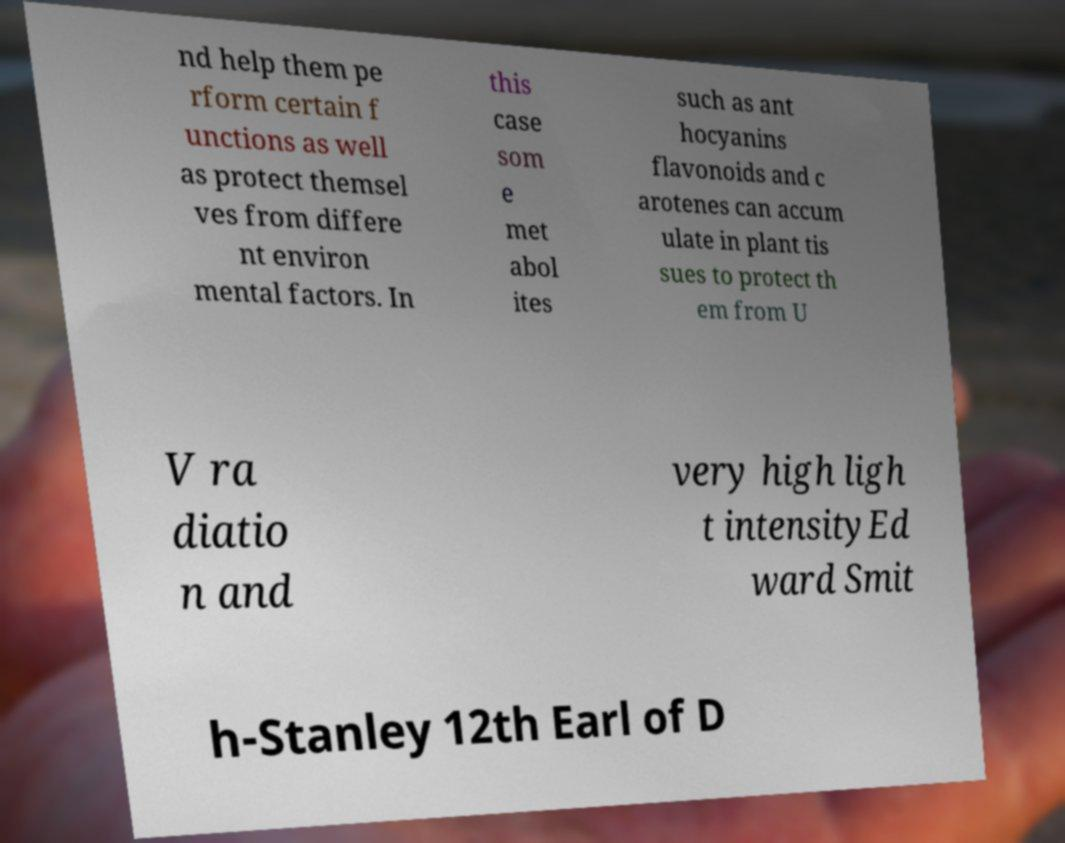I need the written content from this picture converted into text. Can you do that? nd help them pe rform certain f unctions as well as protect themsel ves from differe nt environ mental factors. In this case som e met abol ites such as ant hocyanins flavonoids and c arotenes can accum ulate in plant tis sues to protect th em from U V ra diatio n and very high ligh t intensityEd ward Smit h-Stanley 12th Earl of D 